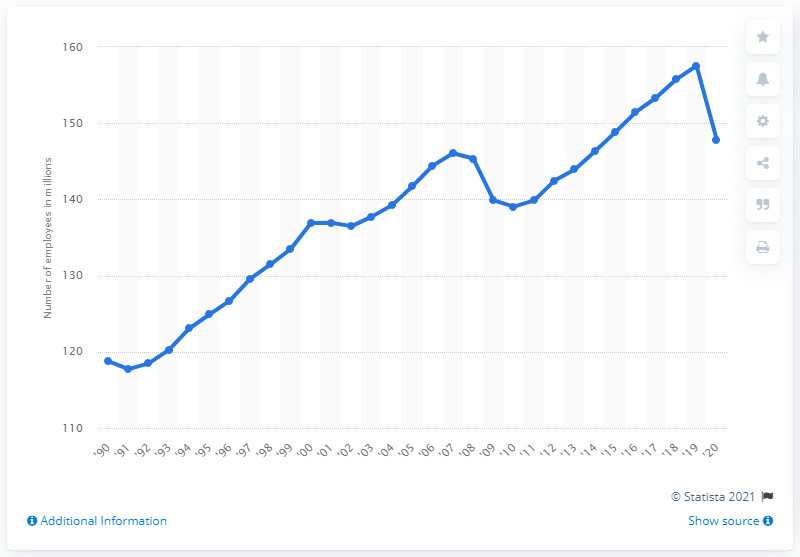Point out several critical features in this image. In 2020, the United States employed 147.79 people. 